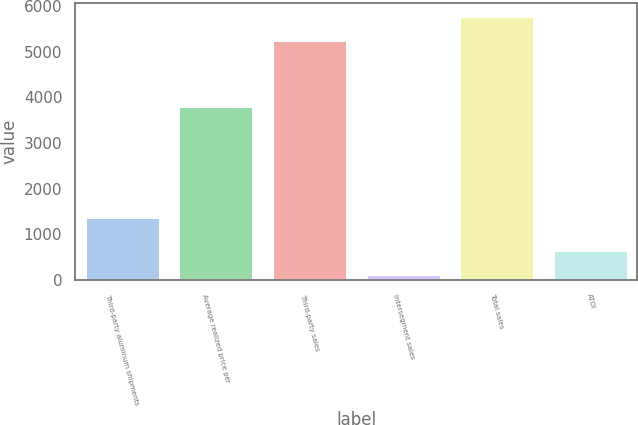Convert chart to OTSL. <chart><loc_0><loc_0><loc_500><loc_500><bar_chart><fcel>Third-party aluminum shipments<fcel>Average realized price per<fcel>Third-party sales<fcel>Intersegment sales<fcel>Total sales<fcel>ATOI<nl><fcel>1375<fcel>3820<fcel>5253<fcel>125<fcel>5778.3<fcel>650.3<nl></chart> 